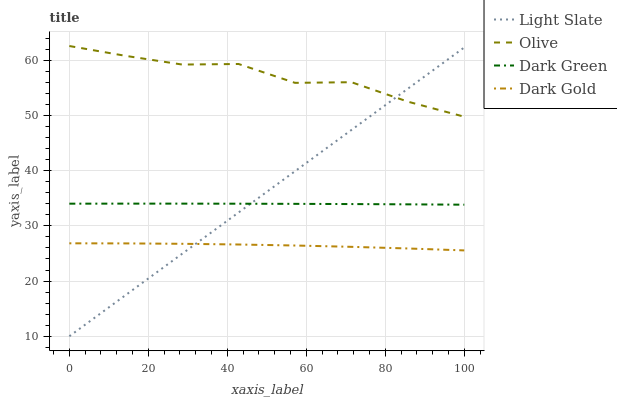Does Dark Gold have the minimum area under the curve?
Answer yes or no. Yes. Does Olive have the maximum area under the curve?
Answer yes or no. Yes. Does Olive have the minimum area under the curve?
Answer yes or no. No. Does Dark Gold have the maximum area under the curve?
Answer yes or no. No. Is Light Slate the smoothest?
Answer yes or no. Yes. Is Olive the roughest?
Answer yes or no. Yes. Is Dark Gold the smoothest?
Answer yes or no. No. Is Dark Gold the roughest?
Answer yes or no. No. Does Light Slate have the lowest value?
Answer yes or no. Yes. Does Dark Gold have the lowest value?
Answer yes or no. No. Does Olive have the highest value?
Answer yes or no. Yes. Does Dark Gold have the highest value?
Answer yes or no. No. Is Dark Gold less than Olive?
Answer yes or no. Yes. Is Olive greater than Dark Green?
Answer yes or no. Yes. Does Light Slate intersect Olive?
Answer yes or no. Yes. Is Light Slate less than Olive?
Answer yes or no. No. Is Light Slate greater than Olive?
Answer yes or no. No. Does Dark Gold intersect Olive?
Answer yes or no. No. 